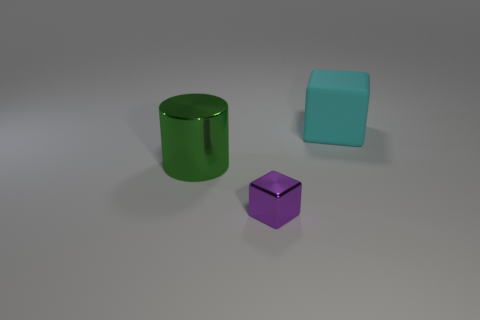Could you guess the material of these objects? Based on the glossy surface and reflections, it's likely that the objects are made of a material like plastic or polished metal. Their smooth texture and the way they reflect light seem characteristic of such materials. 